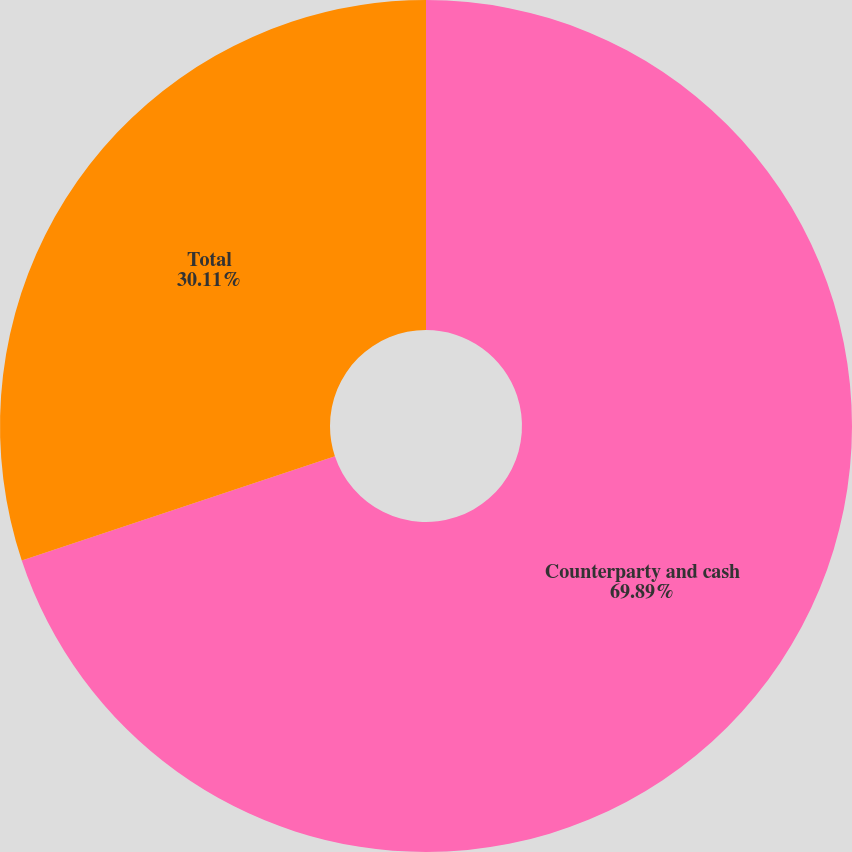<chart> <loc_0><loc_0><loc_500><loc_500><pie_chart><fcel>Counterparty and cash<fcel>Total<nl><fcel>69.89%<fcel>30.11%<nl></chart> 